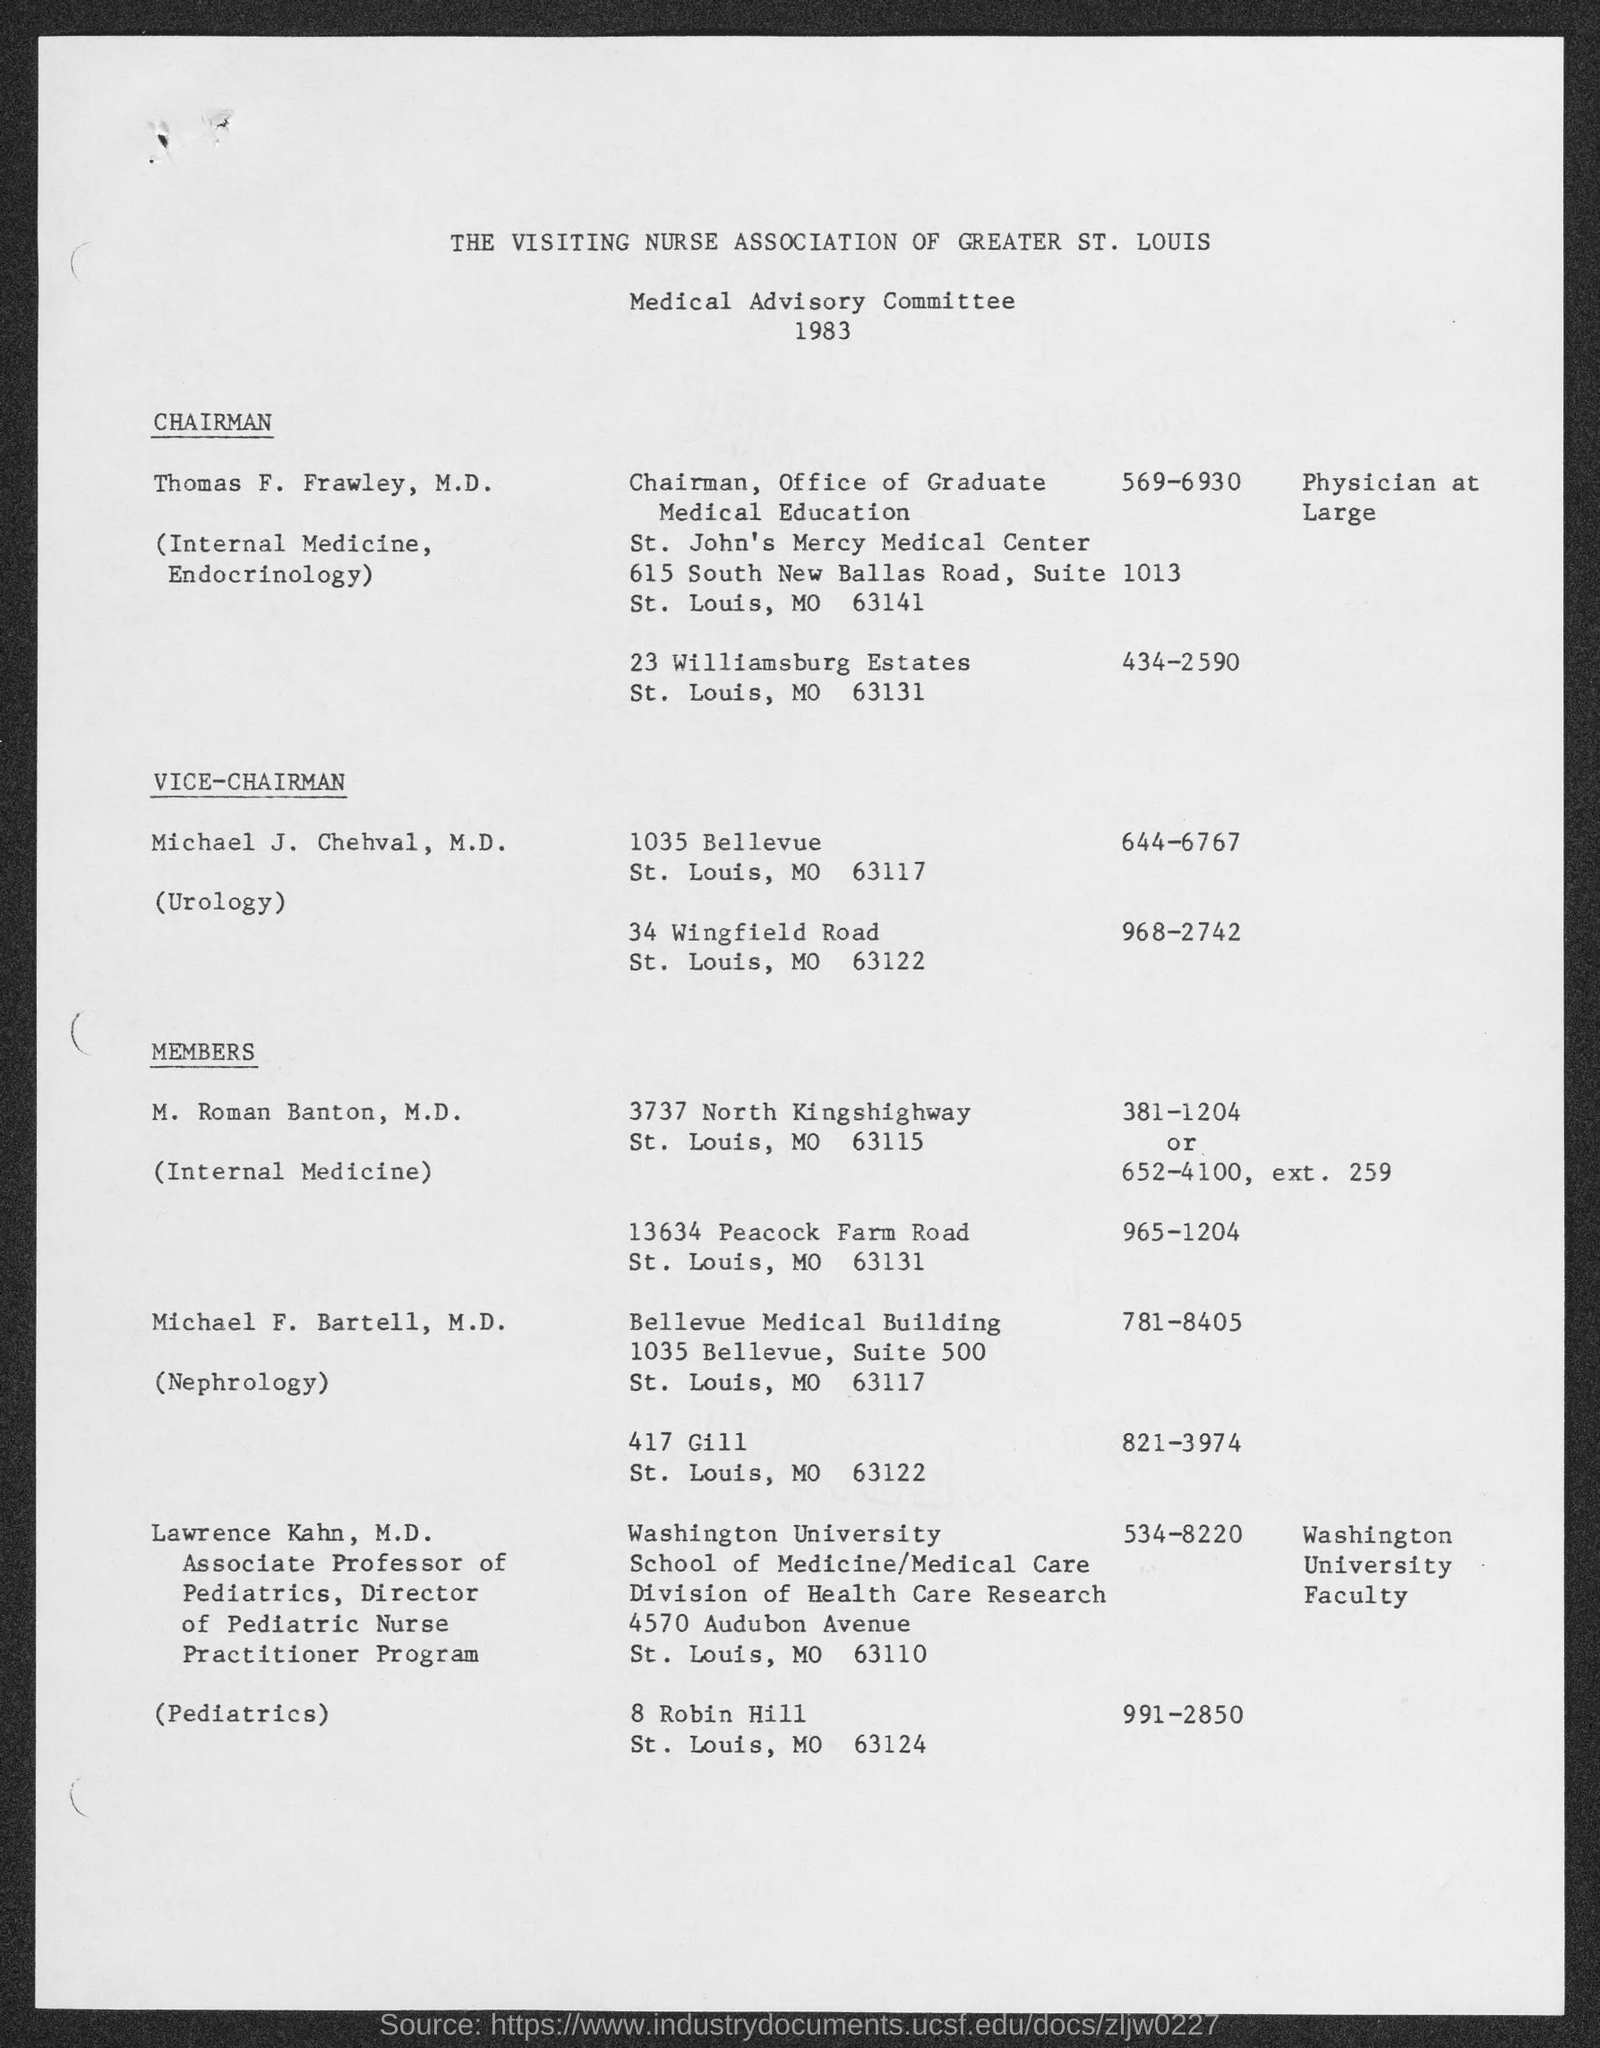For which year is the Medical Advisory Committee?
Keep it short and to the point. 1983. Who is the chairman of the Office of Graduate Medical Education?
Your answer should be compact. Thomas F. Frawley. What is Michael J. Chehval, M.D.'s title?
Provide a succinct answer. Vice-Chairman. What is the phone number of Michael J. Chehval, M.D. at 1035 Bellevue?
Give a very brief answer. 644-6767. 